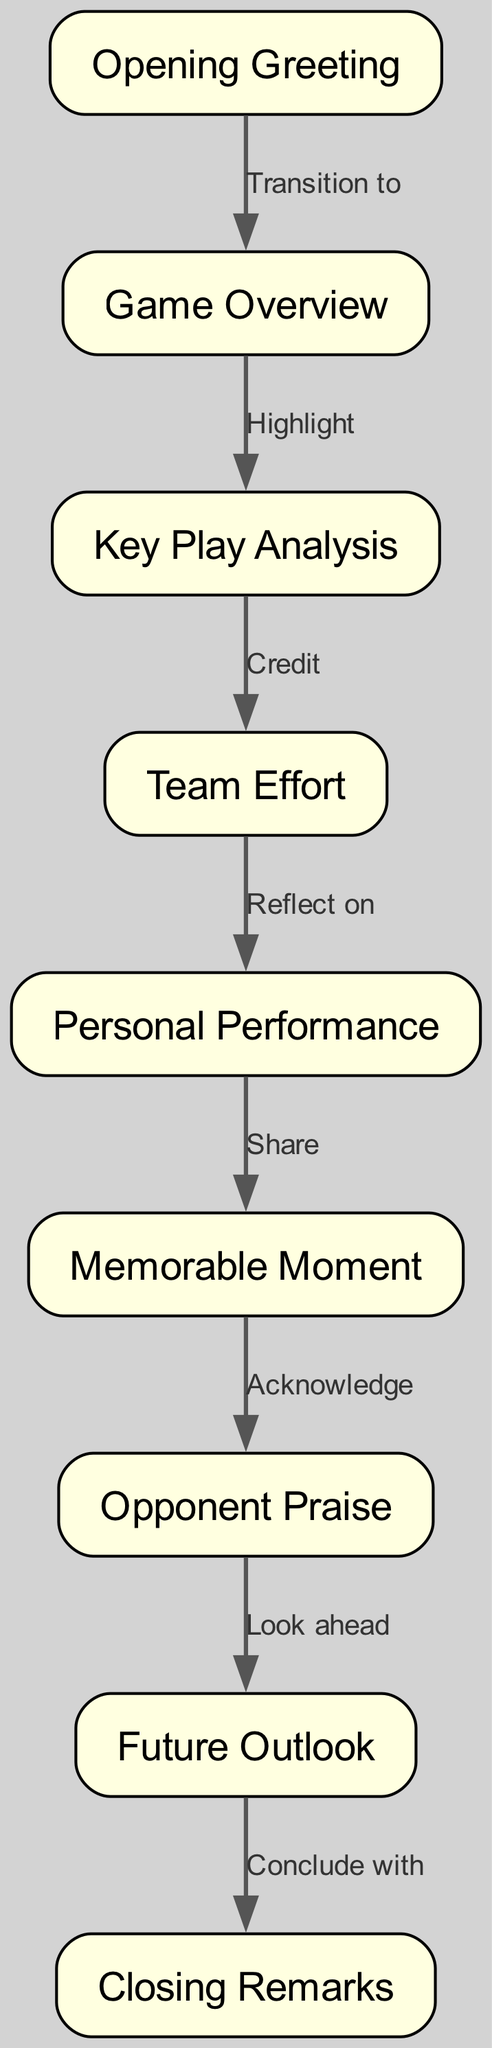What is the first node in the diagram? The first node in the diagram is "Opening Greeting", as it is the starting point before any transitions occur.
Answer: Opening Greeting How many edges are in the diagram? By counting the lines connecting nodes, there are a total of 8 edges that connect the various nodes in the diagram.
Answer: 8 What node follows "Team Effort"? The node that follows "Team Effort" is "Personal Performance", as it is directly connected to it in the flow of the diagram.
Answer: Personal Performance Which node transitions to "Future Outlook"? The node that transitions to "Future Outlook" is "Opponent Praise"; this indicates that after acknowledging the opponent, the discussion moves towards future considerations.
Answer: Opponent Praise What is the last node in the diagram? The last node in the diagram is "Closing Remarks," which concludes the structured flow of the post-game interview.
Answer: Closing Remarks What type of relationship connects "Key Play Analysis" to "Team Effort"? The relationship connecting "Key Play Analysis" to "Team Effort" is labeled "Credit," indicating a recognition of contributions made by the team.
Answer: Credit How many nodes are in the diagram? There are 9 distinct nodes within this directed graph, each representing key points in the storytelling structure.
Answer: 9 What is the transition label between "Memorable Moment" and "Opponent Praise"? The transition label between "Memorable Moment" and "Opponent Praise" is "Acknowledge," indicating that while sharing a memorable moment, the speaker acknowledges the opponent's strengths.
Answer: Acknowledge What is the flow of the diagram from "Game Overview" to "Closing Remarks"? The flow begins at "Game Overview," transitions to "Key Play Analysis," then to "Team Effort," followed by "Personal Performance," leading to "Memorable Moment," "Opponent Praise," and finally ends at "Future Outlook" before reaching "Closing Remarks."
Answer: Game Overview → Key Play Analysis → Team Effort → Personal Performance → Memorable Moment → Opponent Praise → Future Outlook → Closing Remarks 